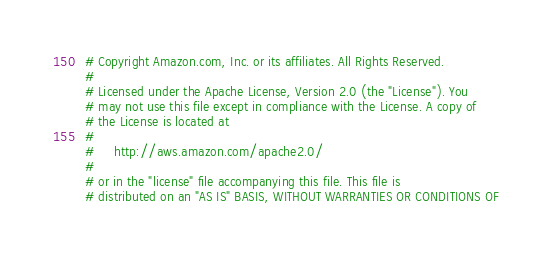<code> <loc_0><loc_0><loc_500><loc_500><_Python_># Copyright Amazon.com, Inc. or its affiliates. All Rights Reserved.
#
# Licensed under the Apache License, Version 2.0 (the "License"). You
# may not use this file except in compliance with the License. A copy of
# the License is located at
#
#     http://aws.amazon.com/apache2.0/
#
# or in the "license" file accompanying this file. This file is
# distributed on an "AS IS" BASIS, WITHOUT WARRANTIES OR CONDITIONS OF</code> 